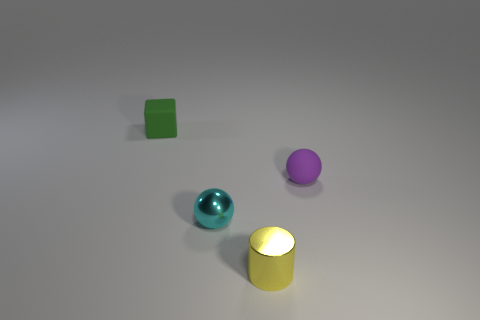Add 2 big cyan things. How many objects exist? 6 Subtract all blue cylinders. Subtract all blue spheres. How many cylinders are left? 1 Subtract all cubes. How many objects are left? 3 Add 4 large purple rubber blocks. How many large purple rubber blocks exist? 4 Subtract 0 blue balls. How many objects are left? 4 Subtract all purple metallic cubes. Subtract all small cyan balls. How many objects are left? 3 Add 4 tiny spheres. How many tiny spheres are left? 6 